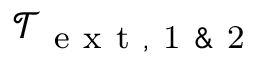<formula> <loc_0><loc_0><loc_500><loc_500>\mathcal { T } _ { e x t , 1 \& 2 }</formula> 